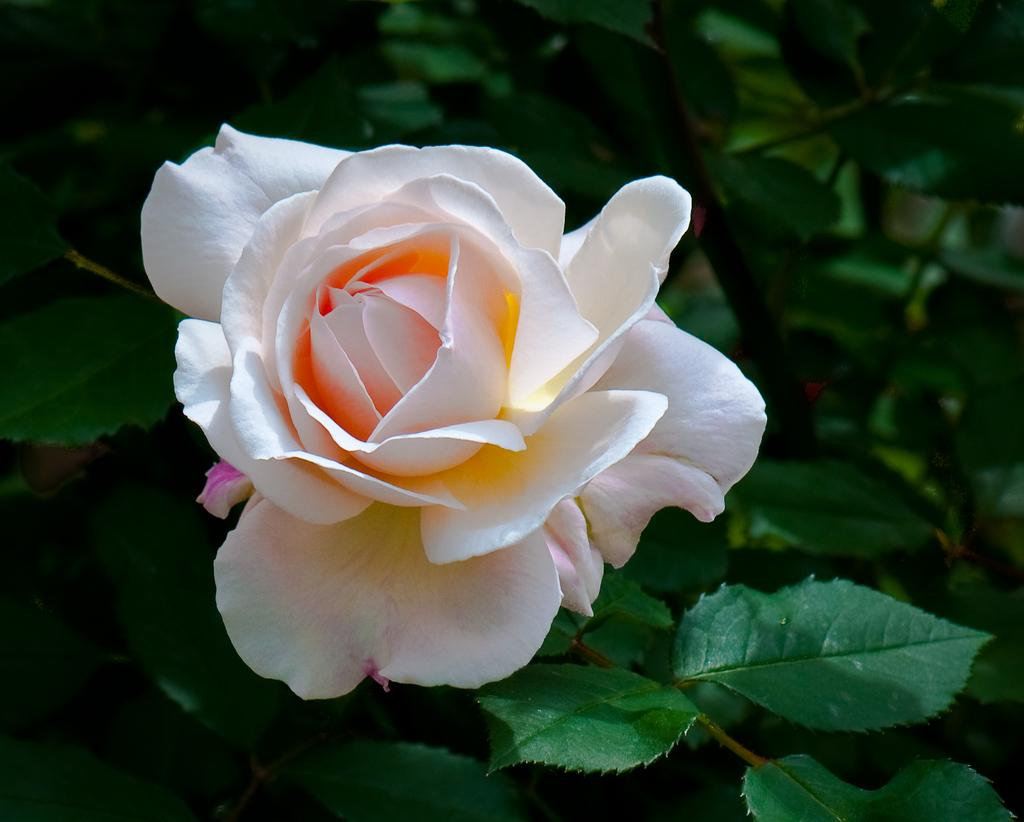What type of living organism can be seen in the image? There is a plant in the image. What specific part of the plant is visible in the image? There is a flower in the image. What type of snake can be seen slithering through the flower in the image? There is no snake present in the image; it only features a plant with a flower. 